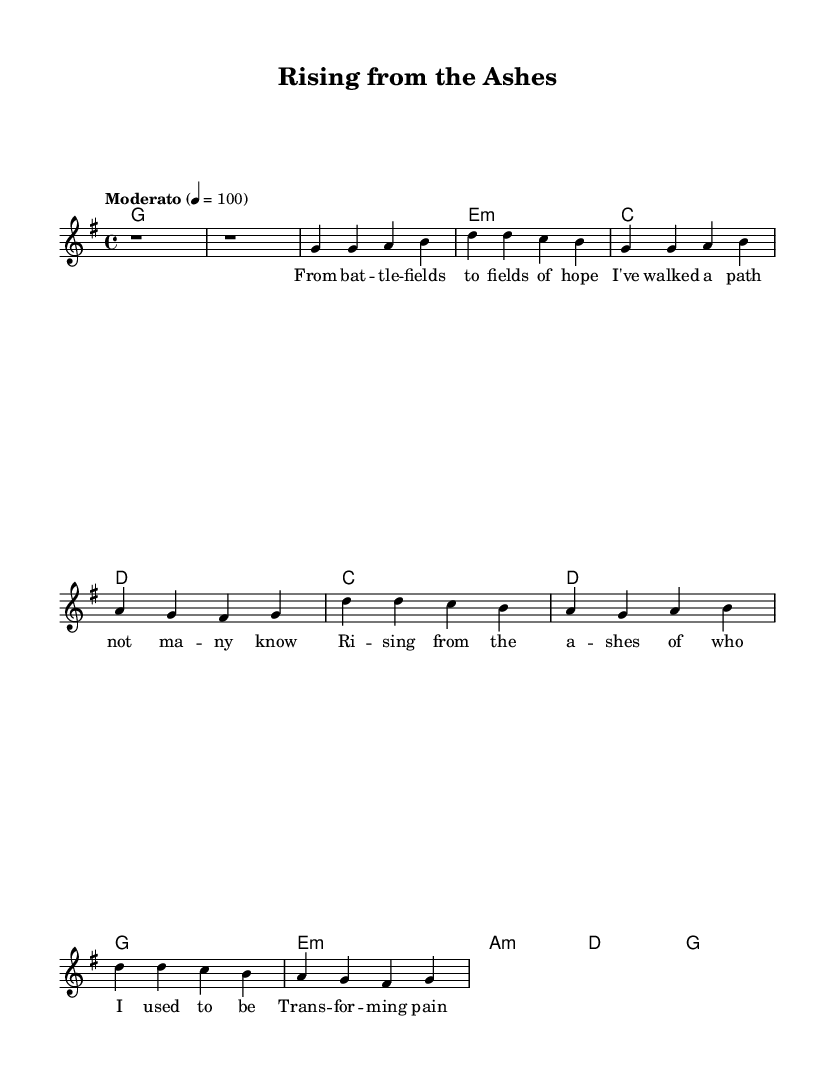What is the key signature of this music? The key signature is G major, which has one sharp (F#). You can identify the key signature by looking at the beginning of the staff where the sharps or flats are notated.
Answer: G major What is the time signature of this piece? The time signature is 4/4, which indicates four beats per measure, and the quarter note gets one beat. The time signature appears at the beginning of the staff, represented by two numbers stacked vertically.
Answer: 4/4 What is the tempo marking for this composition? The tempo marking is "Moderato," indicating a moderate speed for the piece. The tempo is indicated above the staff, often alongside a metronome marking, in this case, 4 = 100.
Answer: Moderato Identify the root chord of the harmony used in the introduction. The root chord in the introduction is G major. In the harmony section, it starts with G and remains throughout the introduction part, indicated next to the melody.
Answer: G What lyrical theme is presented in the chorus? The lyrical theme focuses on personal transformation and freedom from the past, as suggested by phrases like “Rising from the ashes of who I used to be” and “Transforming pain to purpose.” The chorus encapsulates the essence of change and new beginnings, which are common themes in soulful anthems.
Answer: Personal transformation Which musical style does this piece belong to? This piece belongs to the soul genre, characterized by its emotional expressiveness and focus on personal themes, often reflecting deep feelings and transformations experiences. The use of soulful vocals and lyrical content aligns it with the soul music tradition.
Answer: Soul 